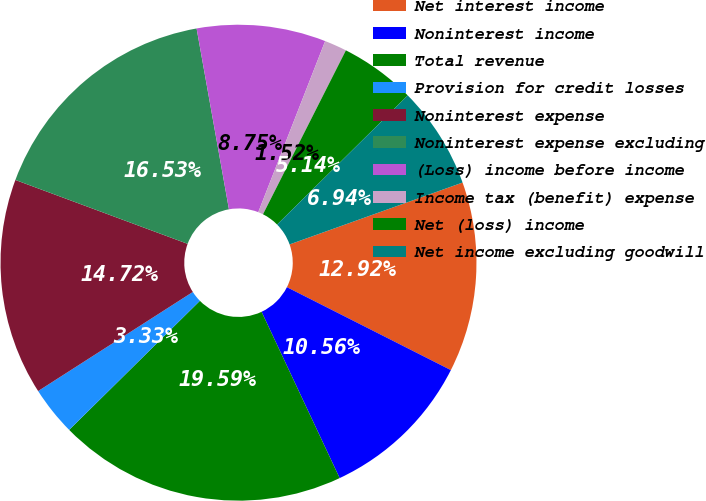Convert chart. <chart><loc_0><loc_0><loc_500><loc_500><pie_chart><fcel>Net interest income<fcel>Noninterest income<fcel>Total revenue<fcel>Provision for credit losses<fcel>Noninterest expense<fcel>Noninterest expense excluding<fcel>(Loss) income before income<fcel>Income tax (benefit) expense<fcel>Net (loss) income<fcel>Net income excluding goodwill<nl><fcel>12.92%<fcel>10.56%<fcel>19.59%<fcel>3.33%<fcel>14.72%<fcel>16.53%<fcel>8.75%<fcel>1.52%<fcel>5.14%<fcel>6.94%<nl></chart> 